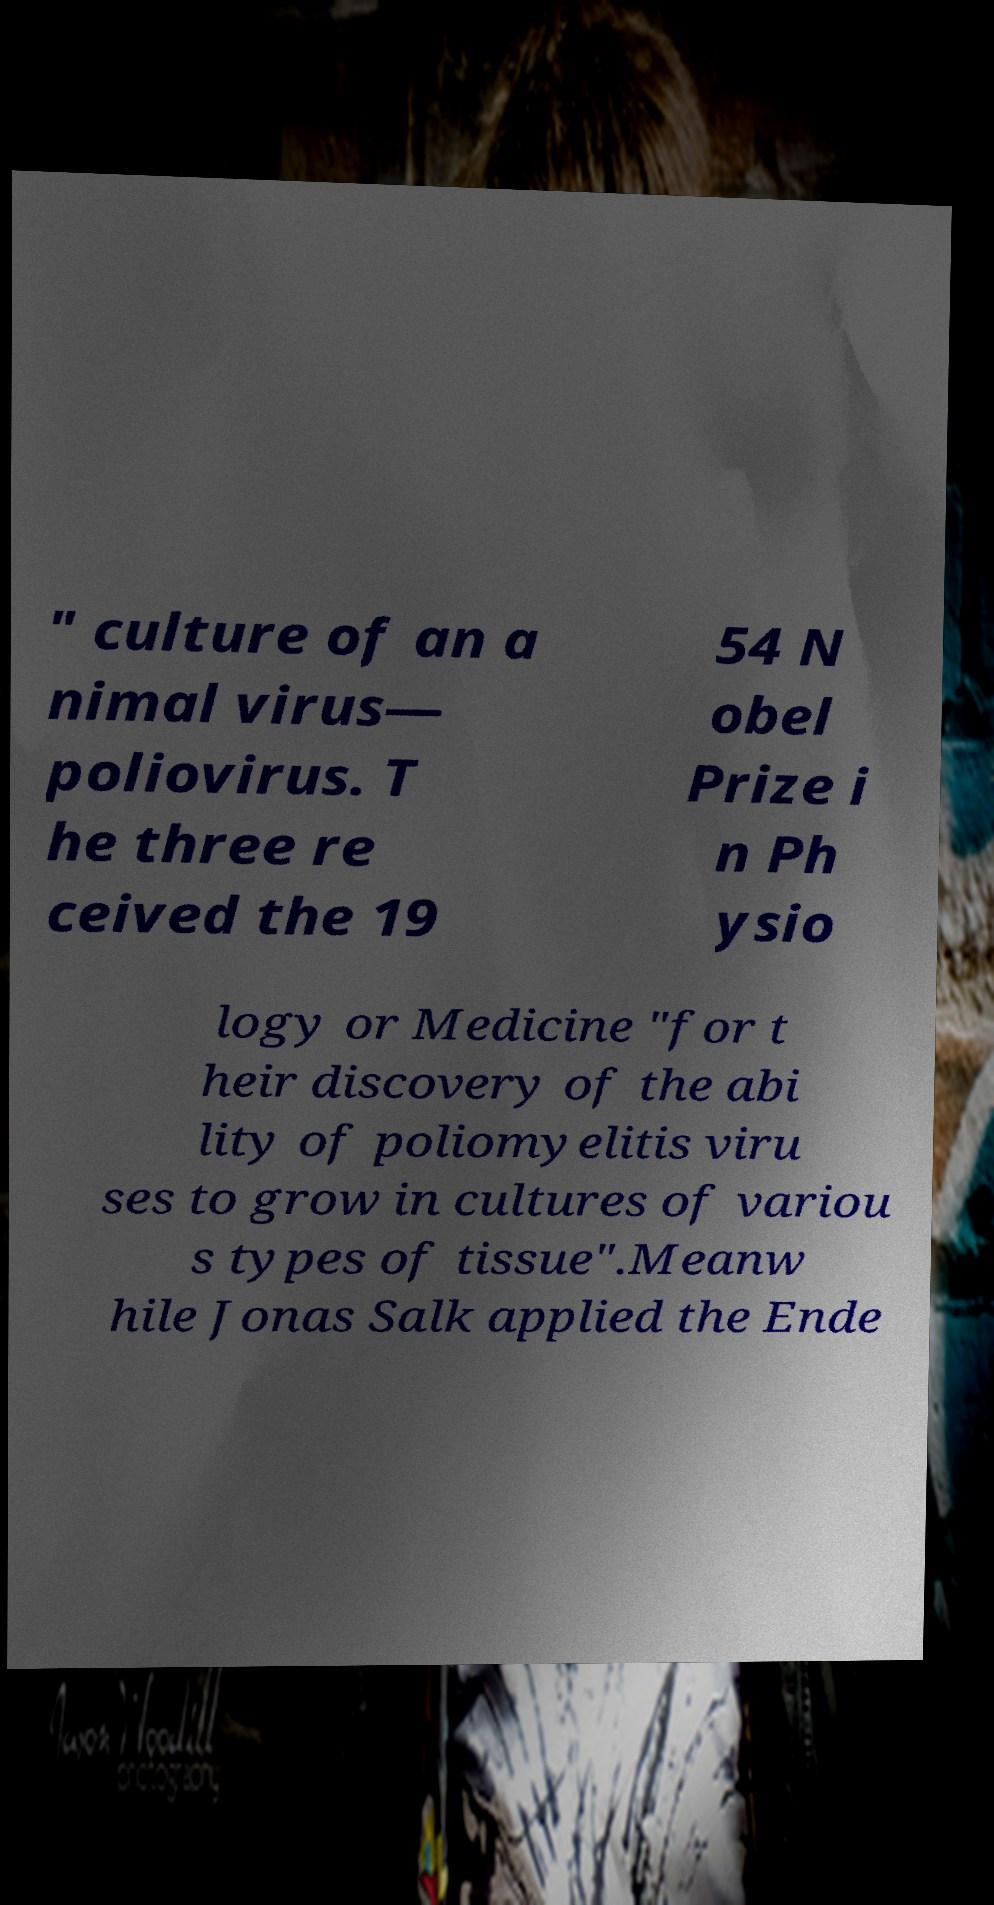Can you read and provide the text displayed in the image?This photo seems to have some interesting text. Can you extract and type it out for me? " culture of an a nimal virus— poliovirus. T he three re ceived the 19 54 N obel Prize i n Ph ysio logy or Medicine "for t heir discovery of the abi lity of poliomyelitis viru ses to grow in cultures of variou s types of tissue".Meanw hile Jonas Salk applied the Ende 